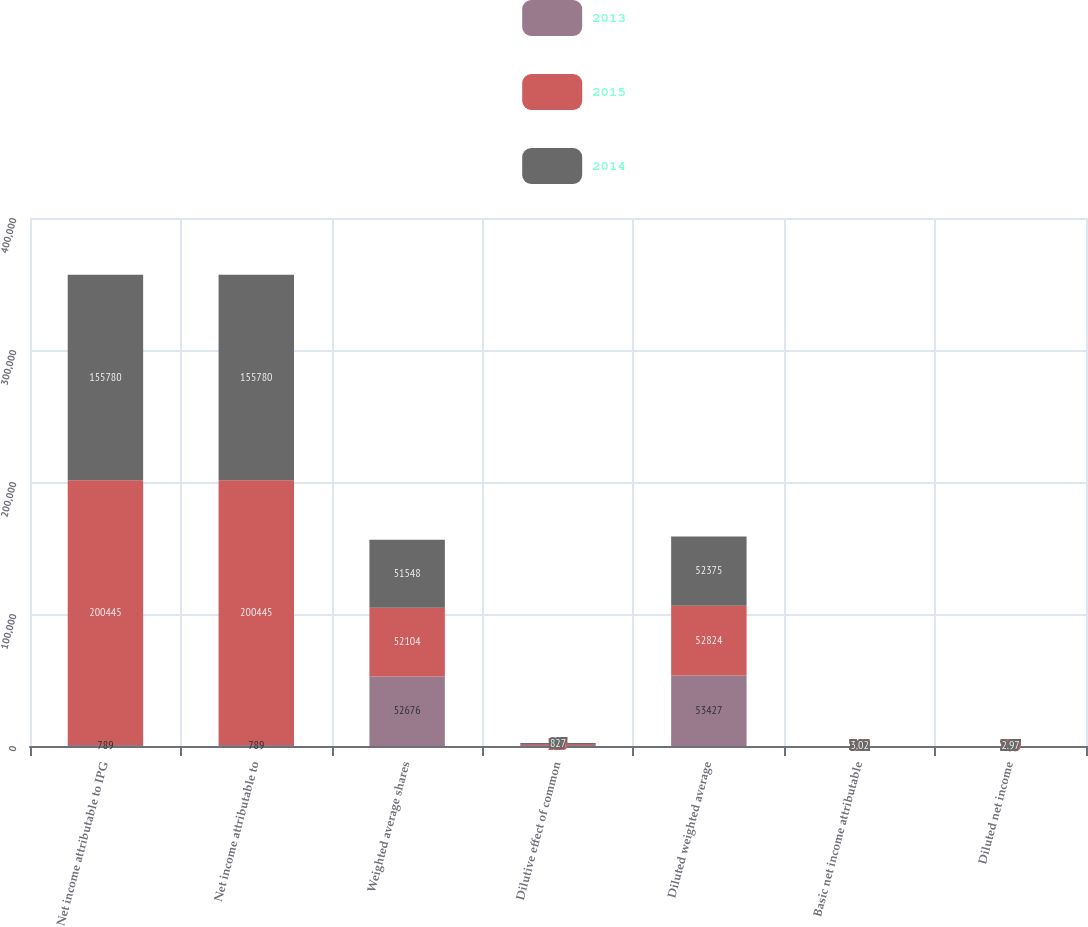<chart> <loc_0><loc_0><loc_500><loc_500><stacked_bar_chart><ecel><fcel>Net income attributable to IPG<fcel>Net income attributable to<fcel>Weighted average shares<fcel>Dilutive effect of common<fcel>Diluted weighted average<fcel>Basic net income attributable<fcel>Diluted net income<nl><fcel>2013<fcel>789<fcel>789<fcel>52676<fcel>751<fcel>53427<fcel>4.6<fcel>4.53<nl><fcel>2015<fcel>200445<fcel>200445<fcel>52104<fcel>720<fcel>52824<fcel>3.85<fcel>3.79<nl><fcel>2014<fcel>155780<fcel>155780<fcel>51548<fcel>827<fcel>52375<fcel>3.02<fcel>2.97<nl></chart> 